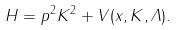<formula> <loc_0><loc_0><loc_500><loc_500>H = p ^ { 2 } K ^ { 2 } + V ( x , K , { \mathit \Lambda } ) .</formula> 